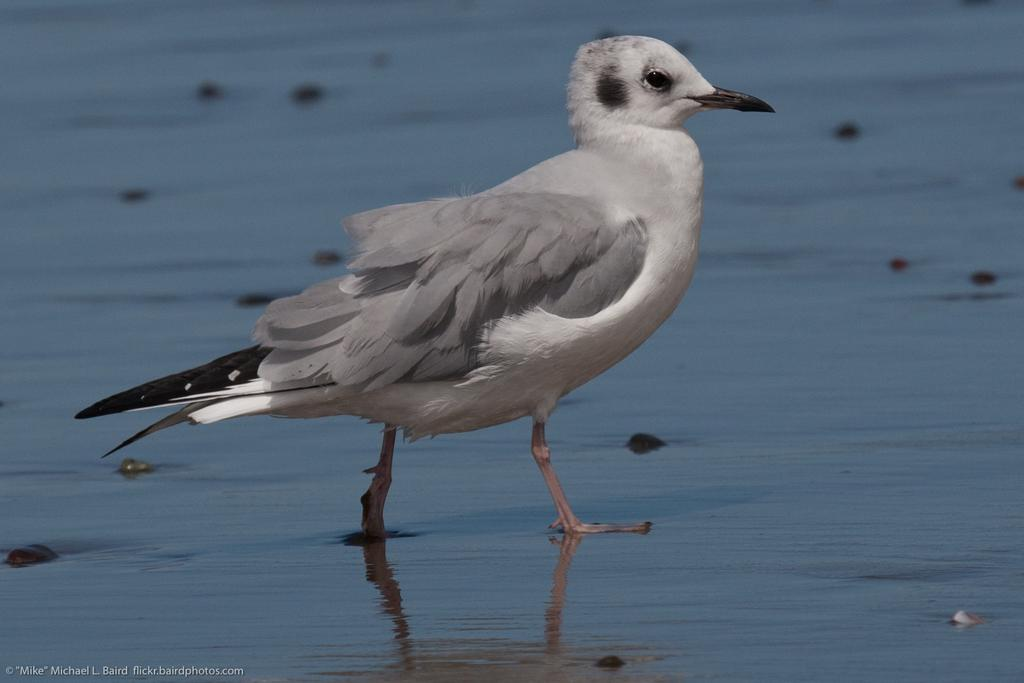What type of animal can be seen in the image? There is a bird in the image. What is the bird situated in? The bird is situated in water. Is there any additional information or marking in the image? Yes, there is a watermark at the bottom left of the image. What type of curtain can be seen hanging in the image? There is no curtain present in the image; it features a bird in water. Can you explain the robin's theory about the bird's behavior in the image? There is no robin or theory mentioned in the image; it only shows a bird in water with a watermark. 